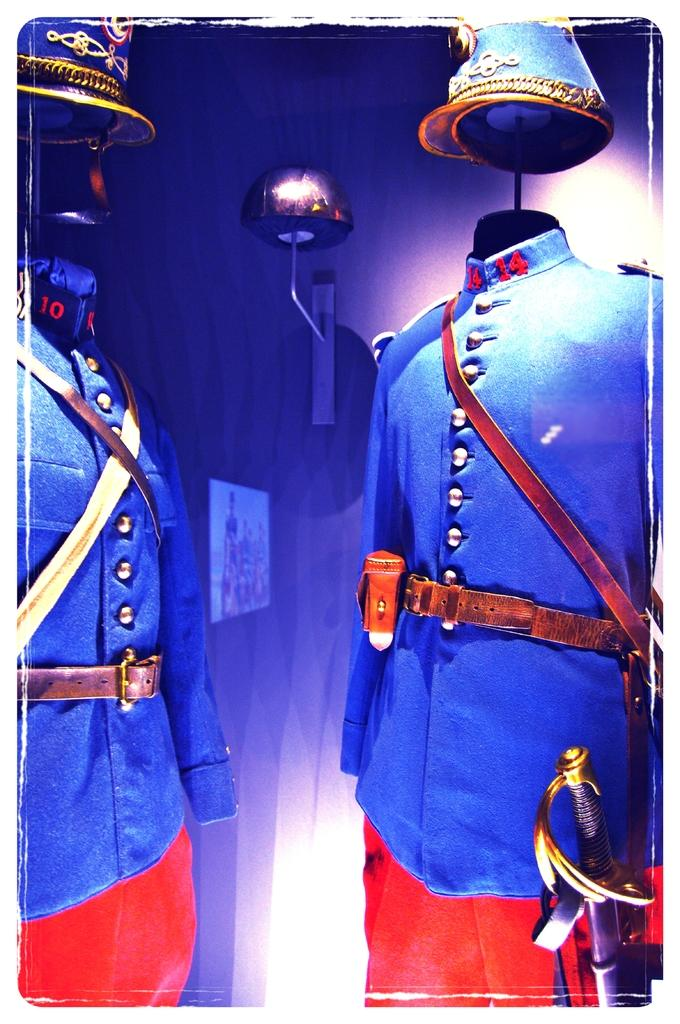What type of clothing can be seen in the image? There are uniforms in the image. What accessory is present with the uniforms? A sword is present in the image. What type of headwear is visible in the image? There are caps in the image. What colors are the uniforms? The uniforms are blue and red in color. What is the history of the temper in the image? There is no mention of a temper or any historical context in the image. 